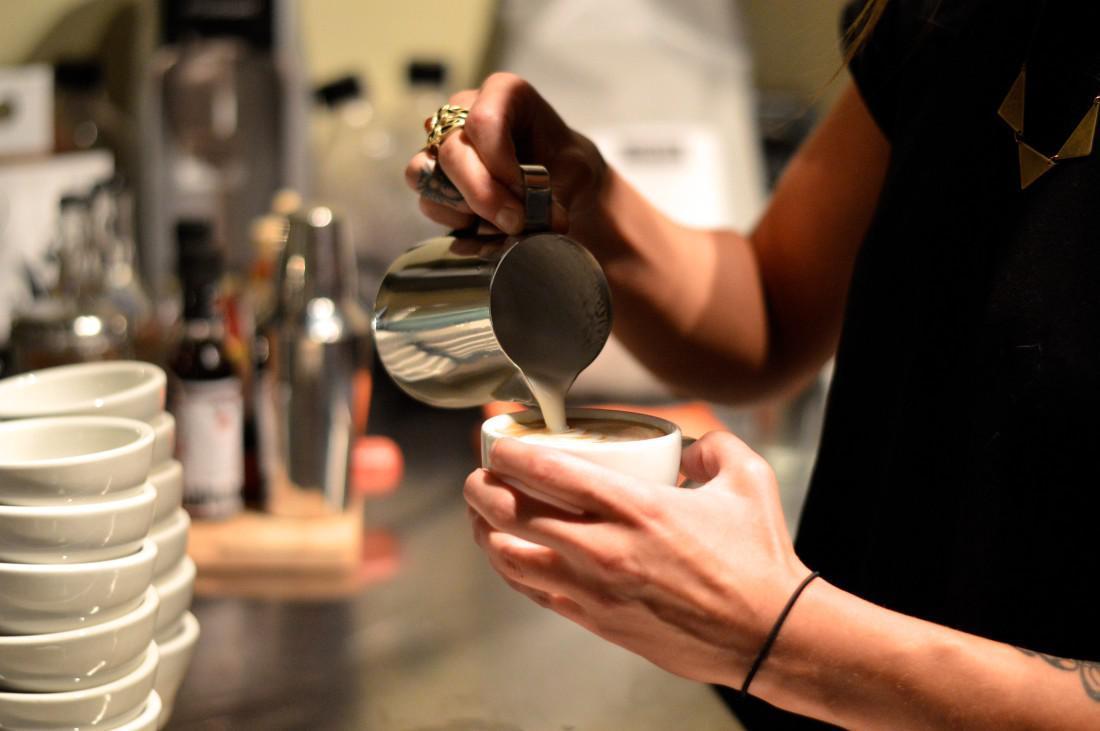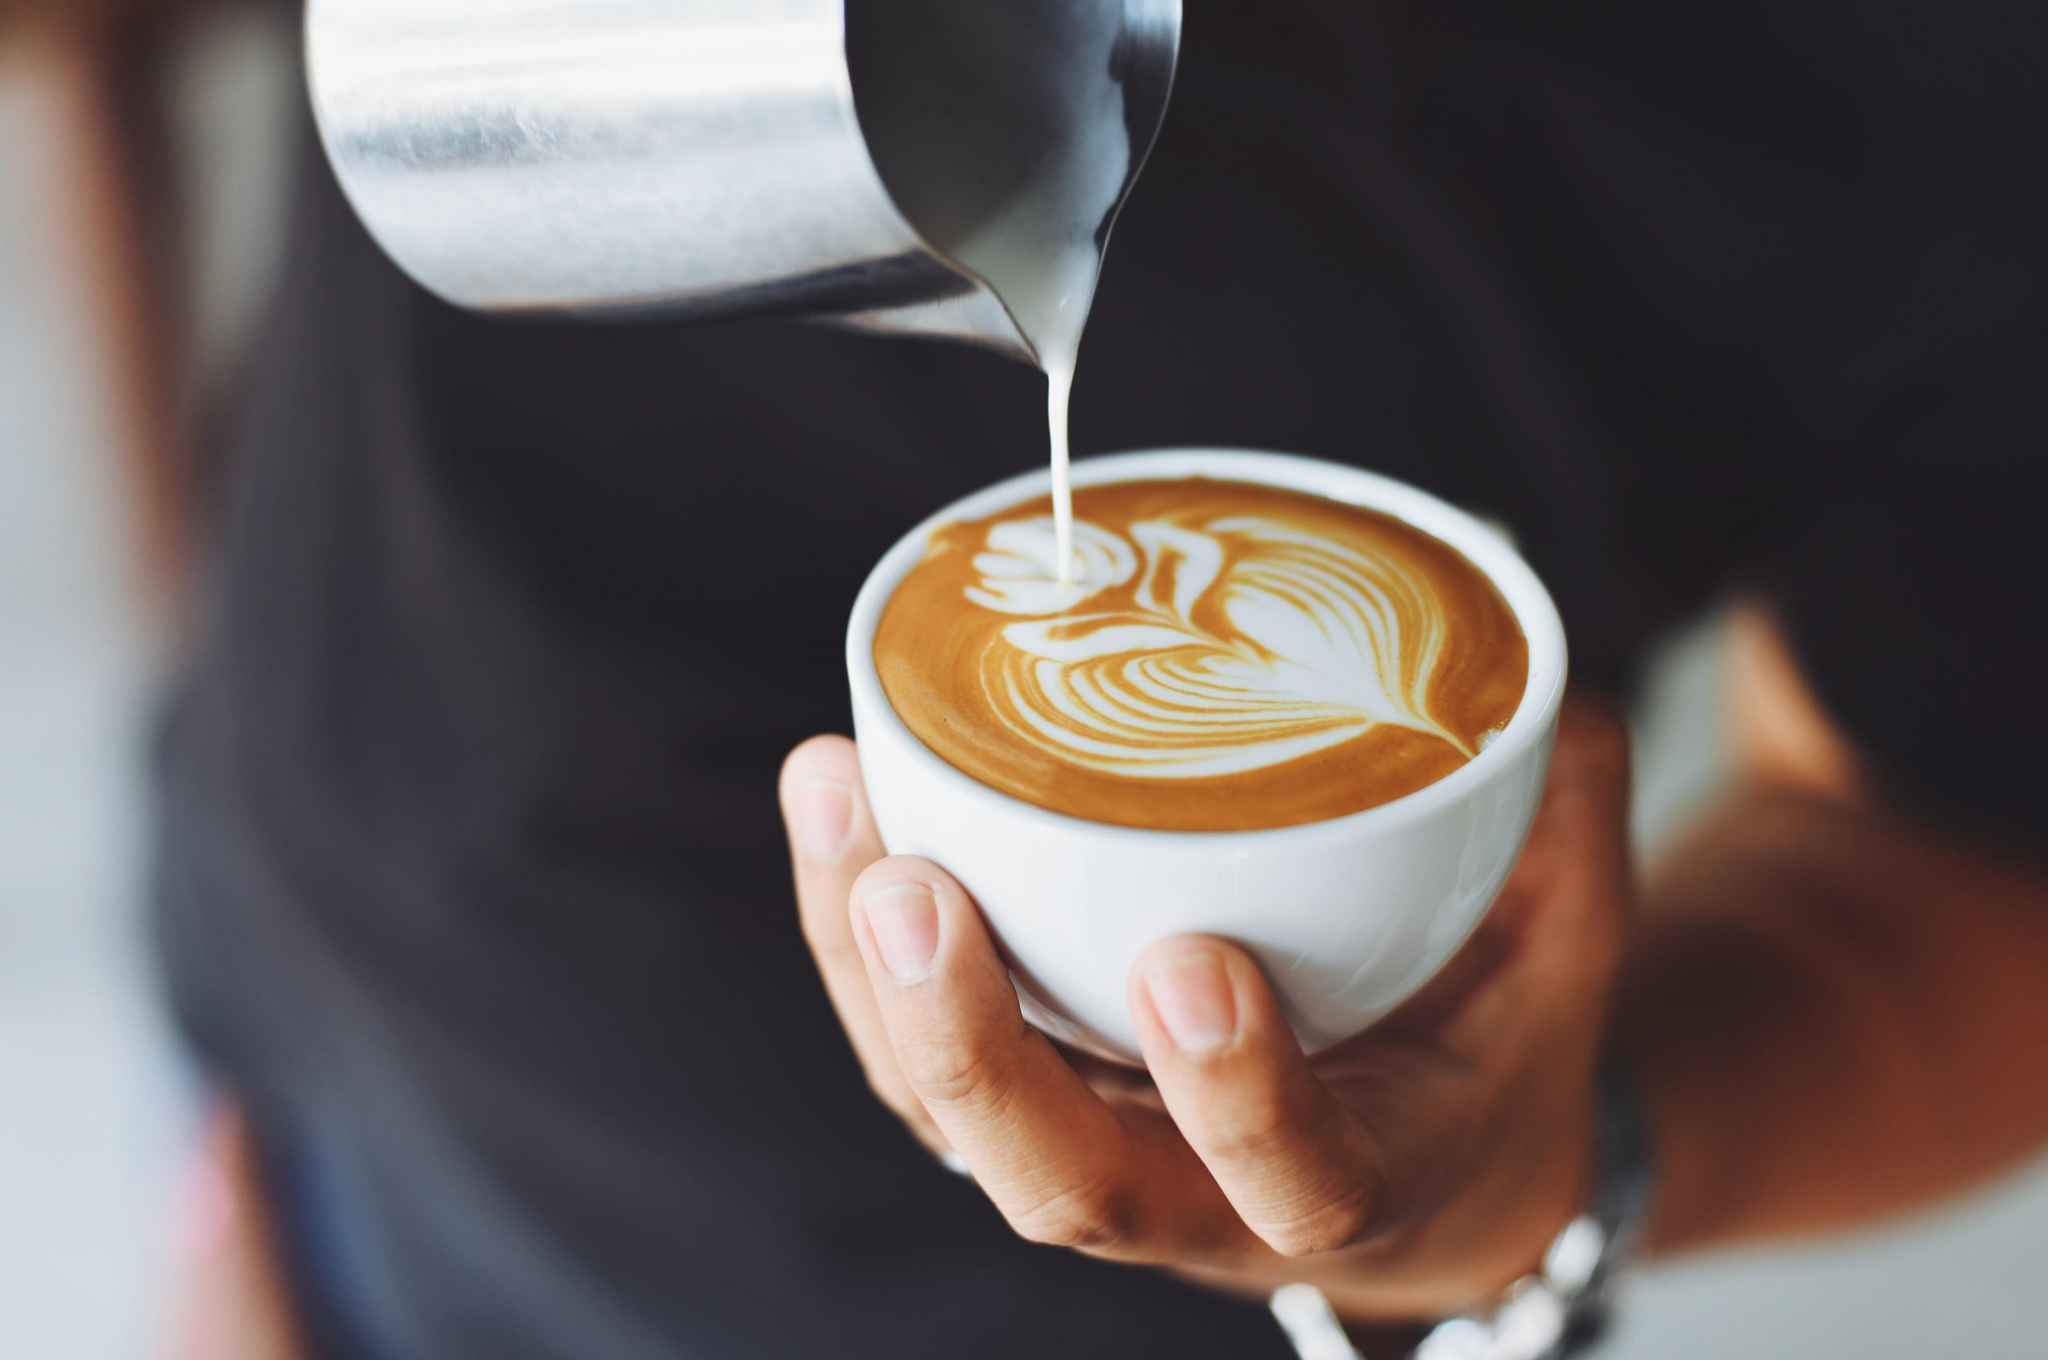The first image is the image on the left, the second image is the image on the right. Evaluate the accuracy of this statement regarding the images: "An image shows one light-colored cup on top of a matching saucer.". Is it true? Answer yes or no. No. The first image is the image on the left, the second image is the image on the right. Evaluate the accuracy of this statement regarding the images: "There are two saucers in total, each holding a coffee cup.". Is it true? Answer yes or no. No. 